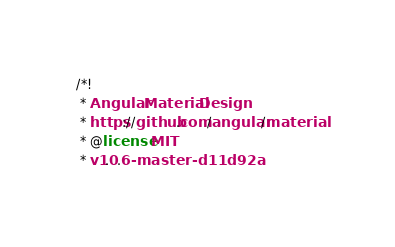<code> <loc_0><loc_0><loc_500><loc_500><_CSS_>/*!
 * Angular Material Design
 * https://github.com/angular/material
 * @license MIT
 * v1.0.6-master-d11d92a</code> 